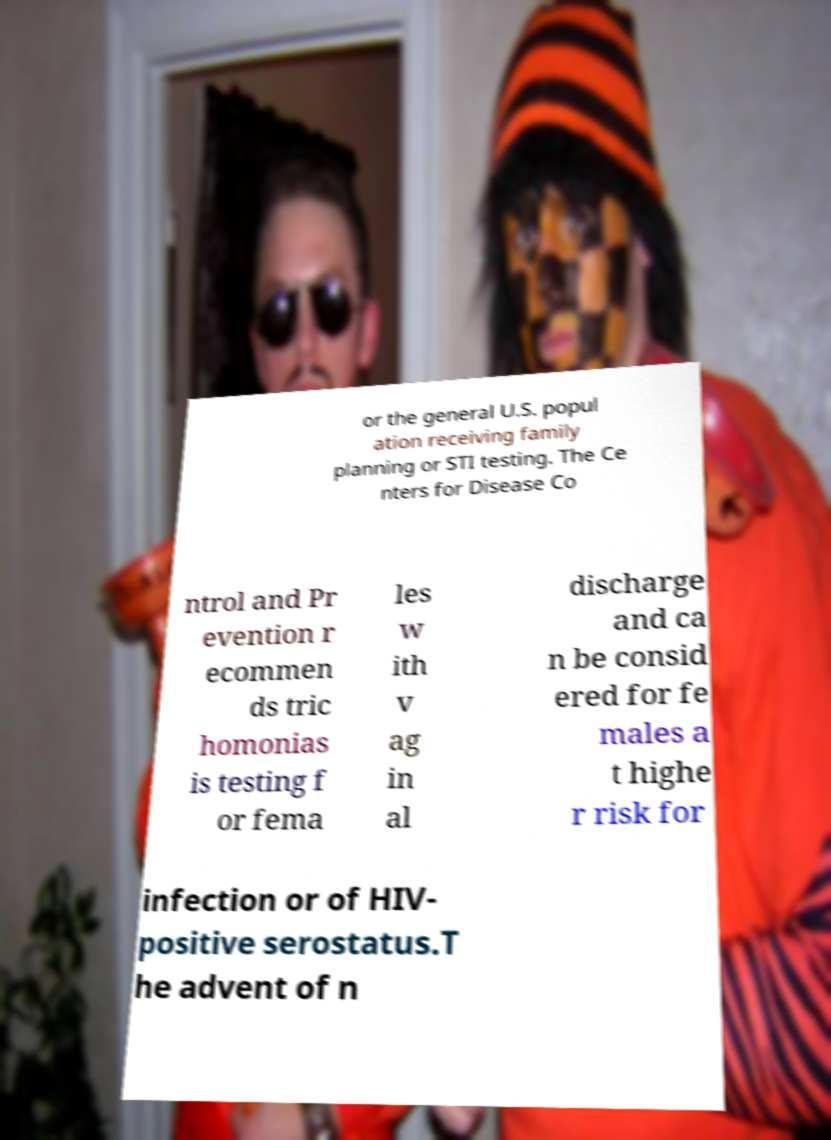Please read and relay the text visible in this image. What does it say? or the general U.S. popul ation receiving family planning or STI testing. The Ce nters for Disease Co ntrol and Pr evention r ecommen ds tric homonias is testing f or fema les w ith v ag in al discharge and ca n be consid ered for fe males a t highe r risk for infection or of HIV- positive serostatus.T he advent of n 